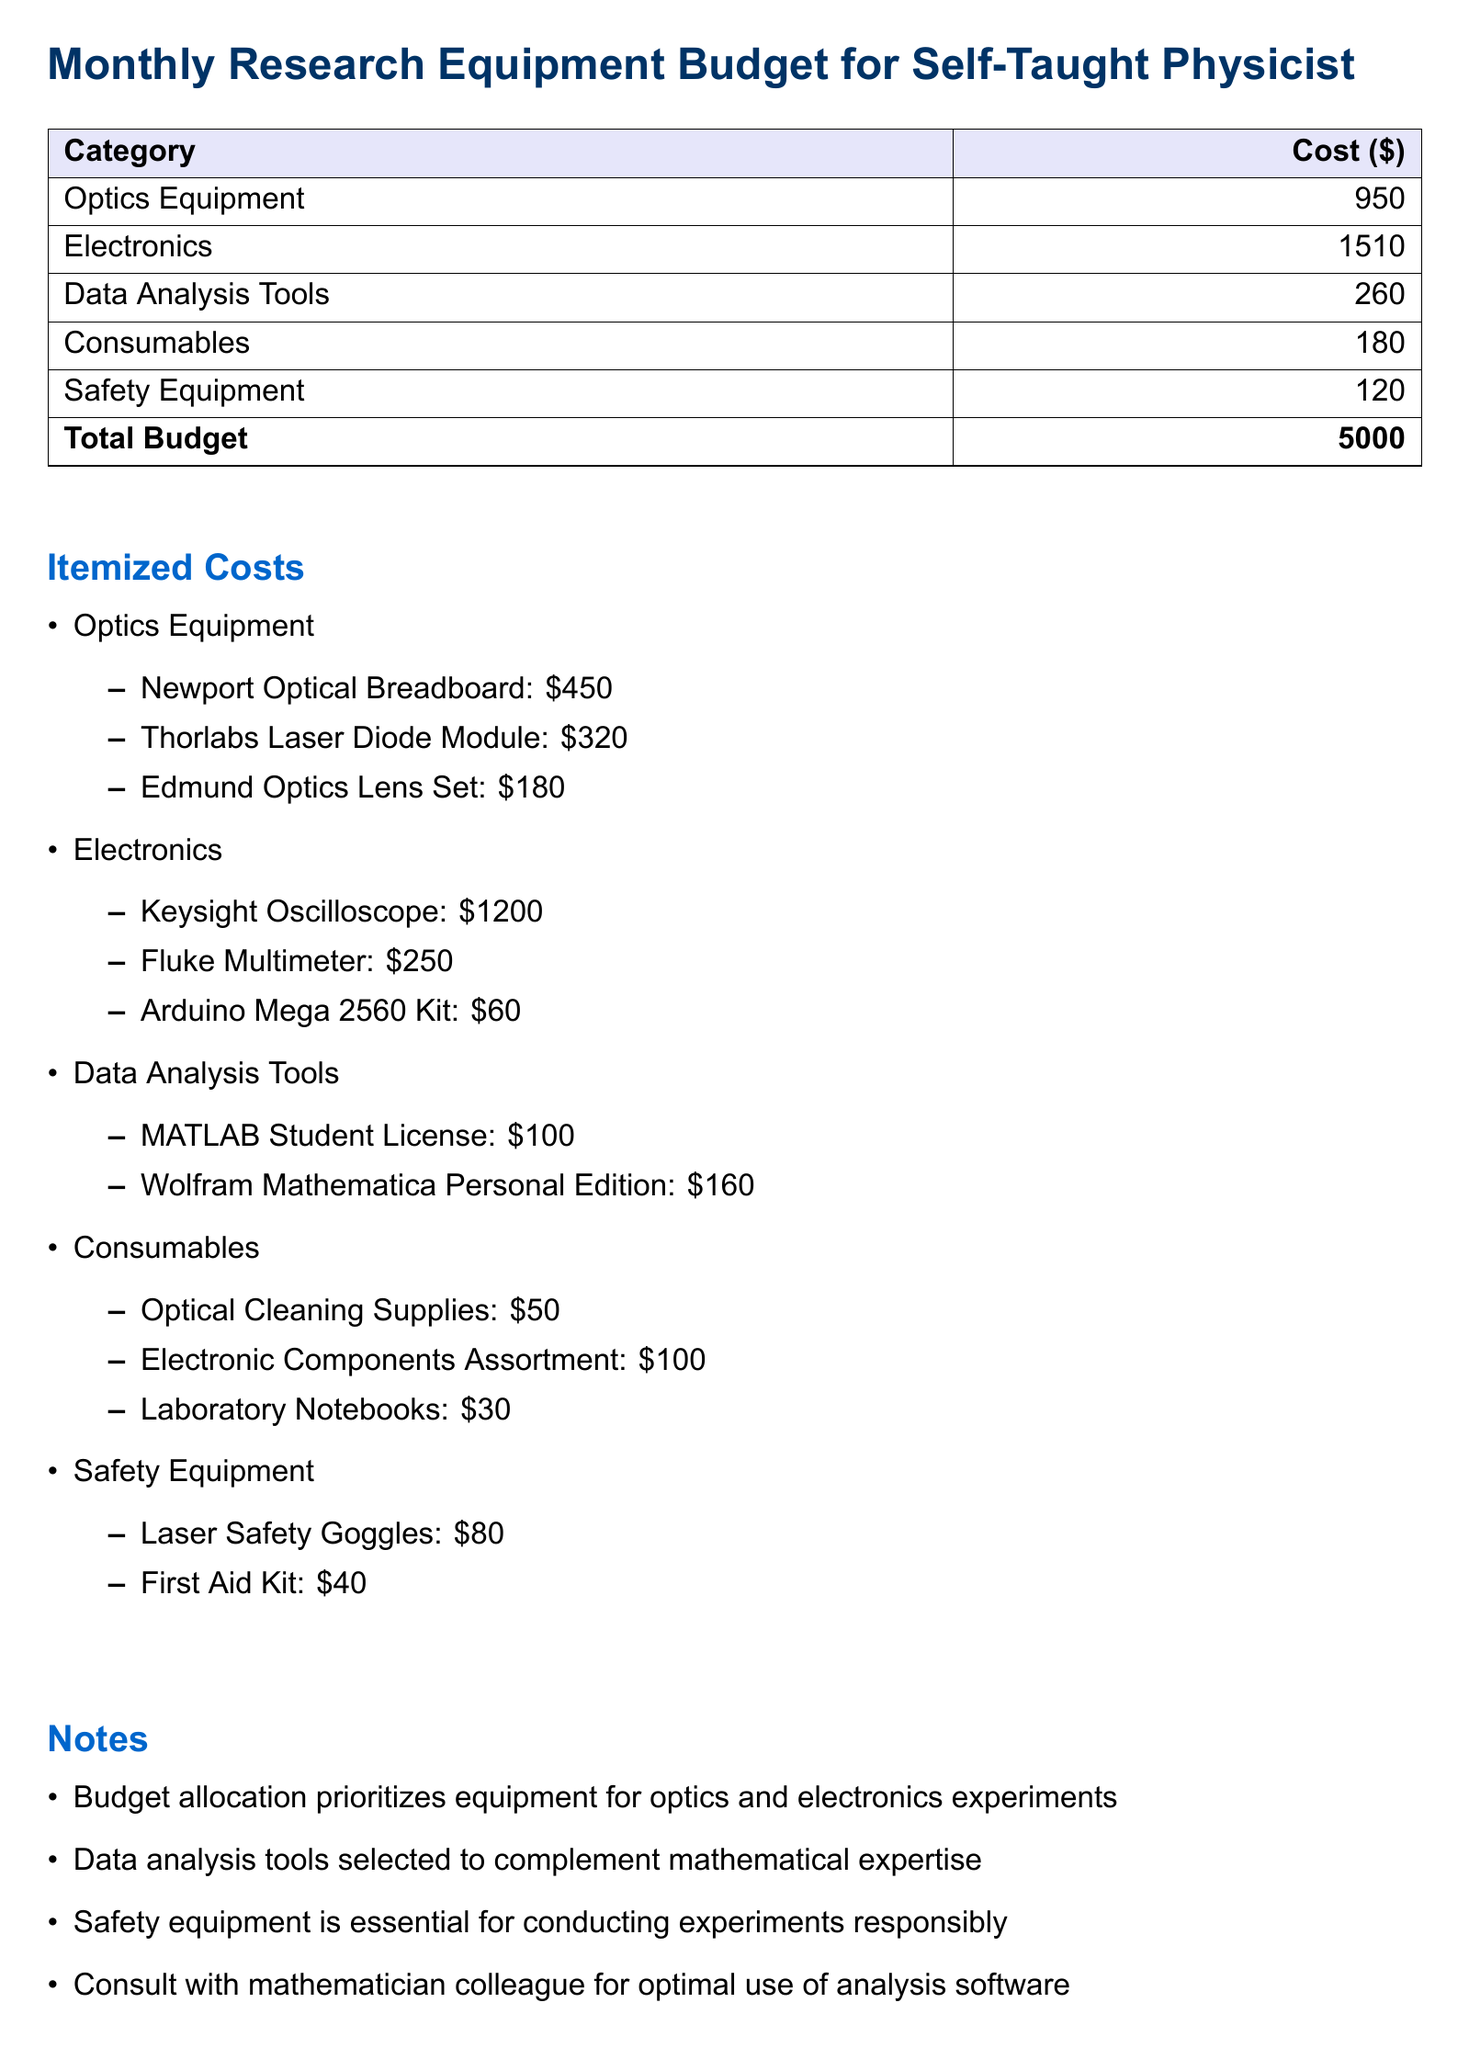What is the total budget? The total budget is explicitly stated at the end of the table in the budget document.
Answer: 5000 How much does the Newport Optical Breadboard cost? The cost of the Newport Optical Breadboard is listed under the optics equipment section of the itemized costs.
Answer: 450 What safety equipment is included in the budget? The document lists specific items of safety equipment under the safety equipment section.
Answer: Laser Safety Goggles, First Aid Kit What is the cost of the Keysight Oscilloscope? The document specifies the price of the Keysight Oscilloscope in the electronics section.
Answer: 1200 How much is allocated for data analysis tools? The budget document clearly states the total amount allocated for data analysis tools in the summary table.
Answer: 260 Which category has the highest expenditure? By comparing the costs listed in the summary table of the budget, we can easily identify the category with the highest expenditure.
Answer: Electronics What item is the most expensive in the optics category? This question requires analyzing the itemized costs listed under optics to identify the highest priced item.
Answer: Thorlabs Laser Diode Module What is the allocation for consumables? The document lists the total budget for consumables directly in the summary table.
Answer: 180 Which item requires consultation with a mathematician? The notes section explicitly mentions an item that requires consultation for optimal use.
Answer: Analysis software 